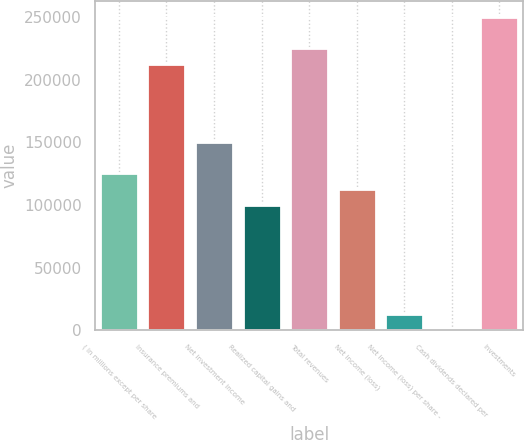Convert chart. <chart><loc_0><loc_0><loc_500><loc_500><bar_chart><fcel>( in millions except per share<fcel>Insurance premiums and<fcel>Net investment income<fcel>Realized capital gains and<fcel>Total revenues<fcel>Net income (loss)<fcel>Net income (loss) per share -<fcel>Cash dividends declared per<fcel>Investments<nl><fcel>125193<fcel>212828<fcel>150231<fcel>100155<fcel>225347<fcel>112674<fcel>12520.1<fcel>0.84<fcel>250385<nl></chart> 